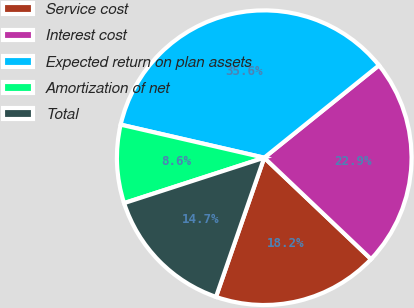Convert chart. <chart><loc_0><loc_0><loc_500><loc_500><pie_chart><fcel>Service cost<fcel>Interest cost<fcel>Expected return on plan assets<fcel>Amortization of net<fcel>Total<nl><fcel>18.22%<fcel>22.87%<fcel>35.61%<fcel>8.59%<fcel>14.7%<nl></chart> 